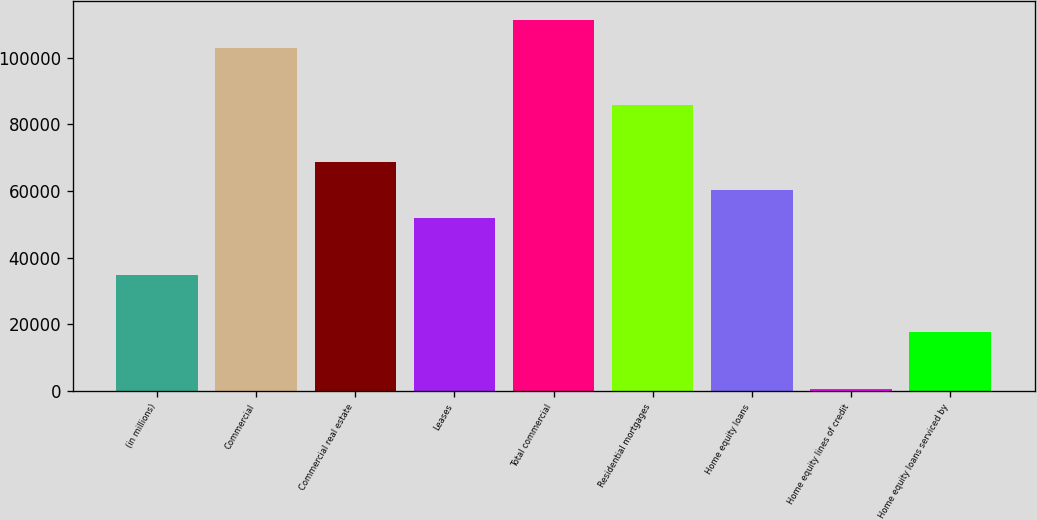<chart> <loc_0><loc_0><loc_500><loc_500><bar_chart><fcel>(in millions)<fcel>Commercial<fcel>Commercial real estate<fcel>Leases<fcel>Total commercial<fcel>Residential mortgages<fcel>Home equity loans<fcel>Home equity lines of credit<fcel>Home equity loans serviced by<nl><fcel>34751<fcel>102895<fcel>68823<fcel>51787<fcel>111413<fcel>85859<fcel>60305<fcel>679<fcel>17715<nl></chart> 